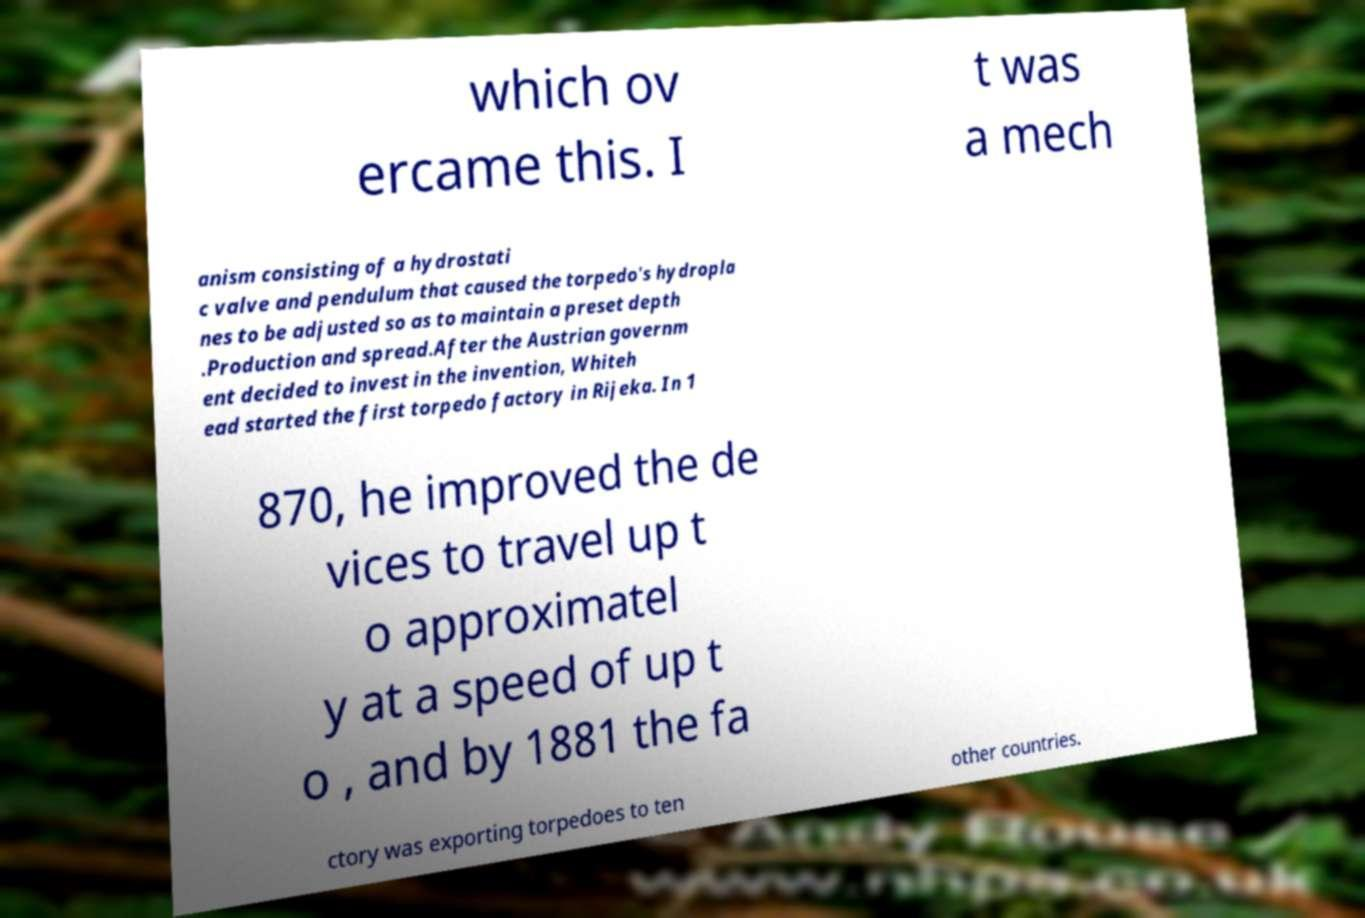Can you accurately transcribe the text from the provided image for me? which ov ercame this. I t was a mech anism consisting of a hydrostati c valve and pendulum that caused the torpedo's hydropla nes to be adjusted so as to maintain a preset depth .Production and spread.After the Austrian governm ent decided to invest in the invention, Whiteh ead started the first torpedo factory in Rijeka. In 1 870, he improved the de vices to travel up t o approximatel y at a speed of up t o , and by 1881 the fa ctory was exporting torpedoes to ten other countries. 